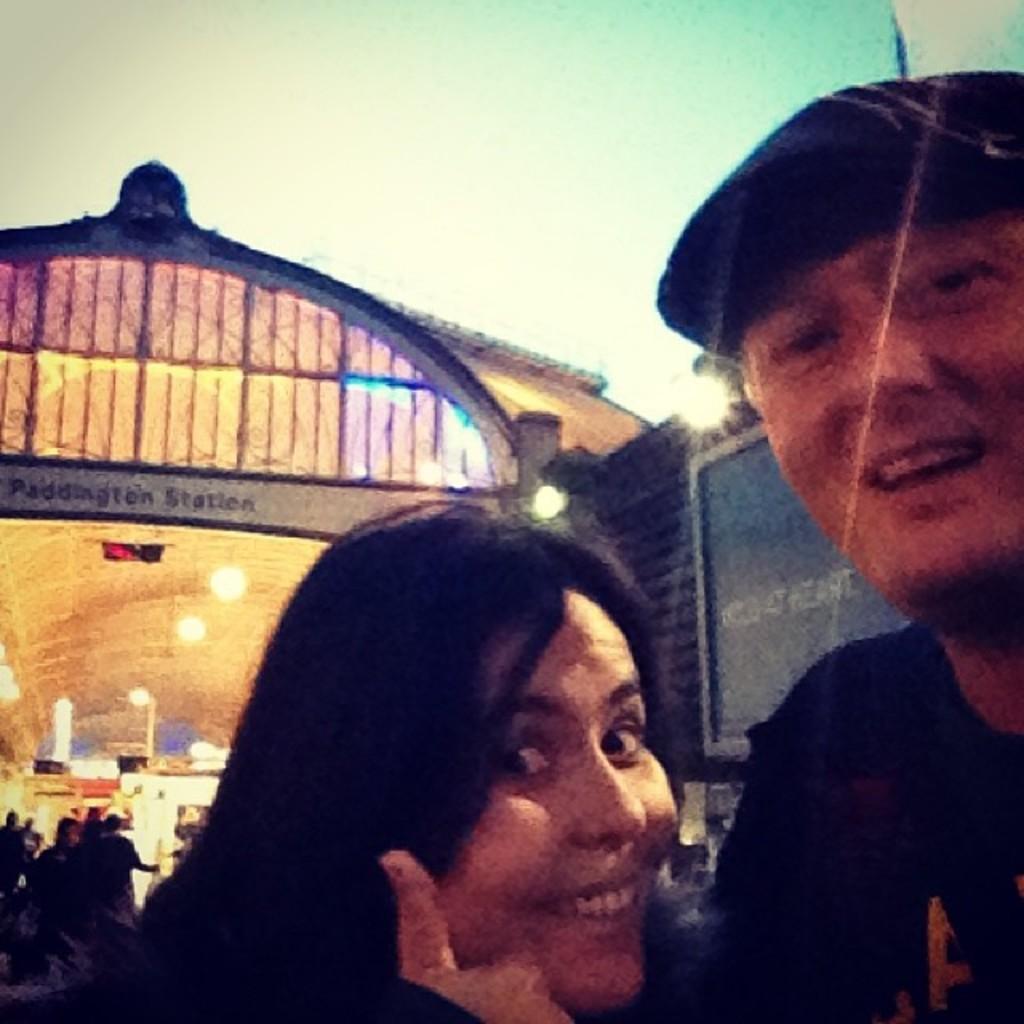Could you give a brief overview of what you see in this image? In this image in the foreground there is one man and one woman who are smiling, and in the background there are some lights, boards, building and some persons and some other objects. 